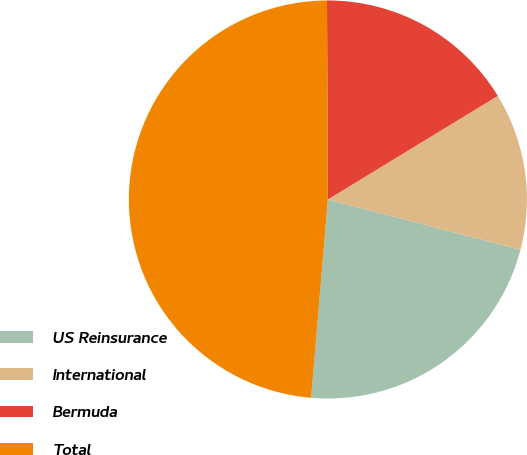Convert chart. <chart><loc_0><loc_0><loc_500><loc_500><pie_chart><fcel>US Reinsurance<fcel>International<fcel>Bermuda<fcel>Total<nl><fcel>22.28%<fcel>12.77%<fcel>16.36%<fcel>48.59%<nl></chart> 